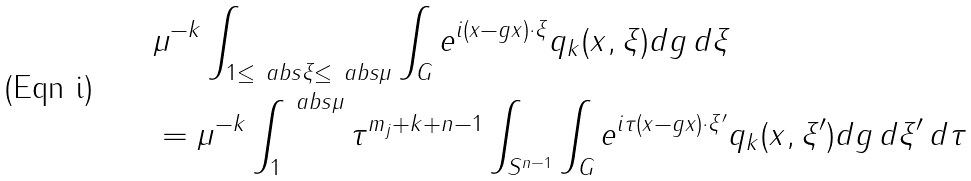Convert formula to latex. <formula><loc_0><loc_0><loc_500><loc_500>& \mu ^ { - k } \int _ { 1 \leq \ a b s \xi \leq \ a b s \mu } \int _ { G } e ^ { i ( x - g x ) \cdot \xi } q _ { k } ( x , \xi ) d g \, d \xi \\ & = \mu ^ { - k } \int _ { 1 } ^ { \ a b s \mu } \tau ^ { m _ { j } + k + n - 1 } \int _ { S ^ { n - 1 } } \int _ { G } e ^ { i \tau ( x - g x ) \cdot \xi ^ { \prime } } q _ { k } ( x , \xi ^ { \prime } ) d g \, d \xi ^ { \prime } \, d \tau</formula> 